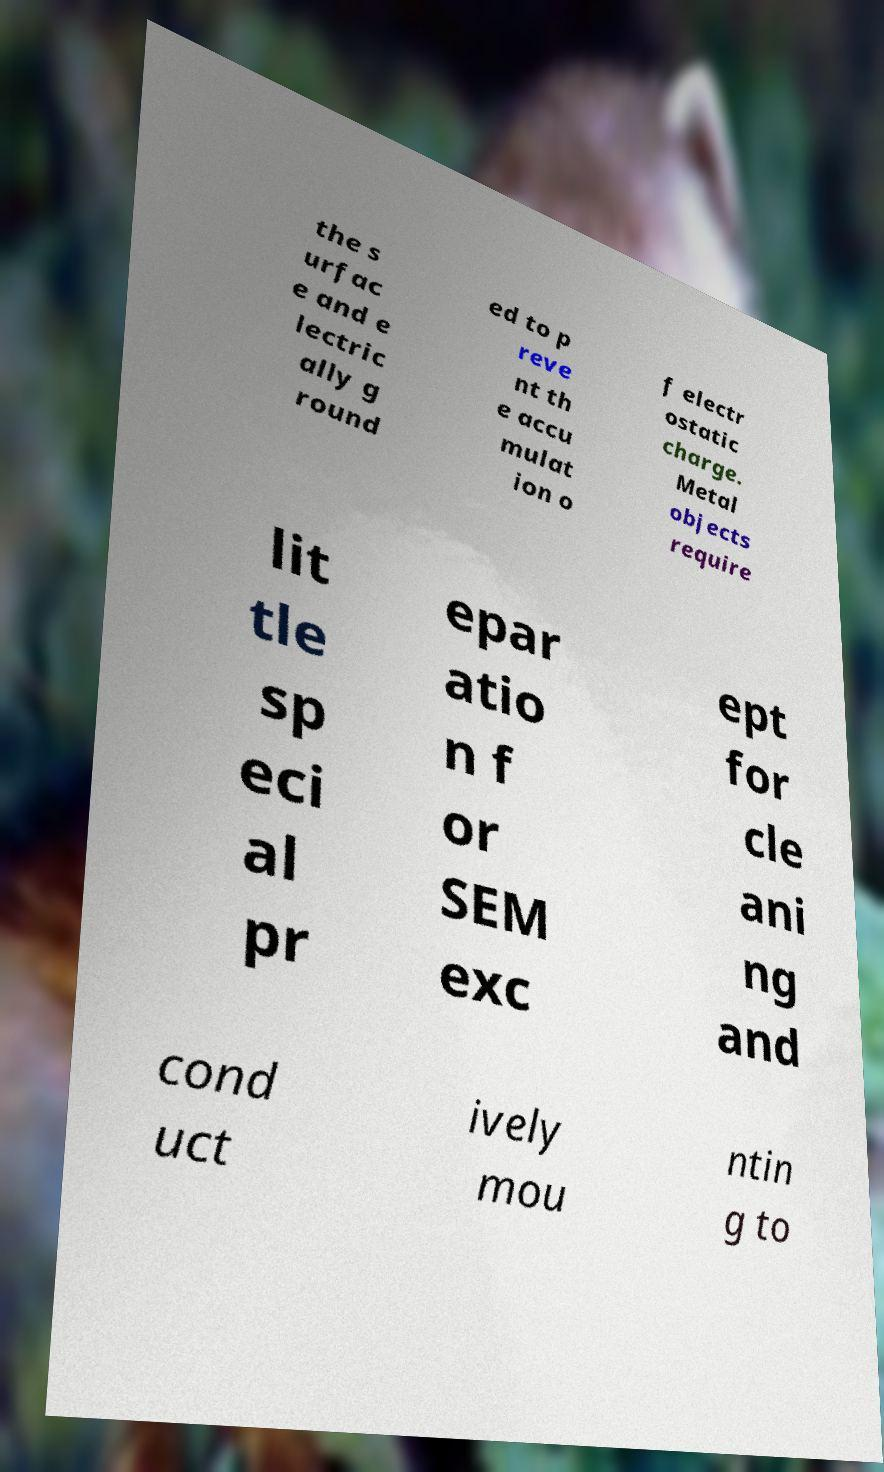For documentation purposes, I need the text within this image transcribed. Could you provide that? the s urfac e and e lectric ally g round ed to p reve nt th e accu mulat ion o f electr ostatic charge. Metal objects require lit tle sp eci al pr epar atio n f or SEM exc ept for cle ani ng and cond uct ively mou ntin g to 